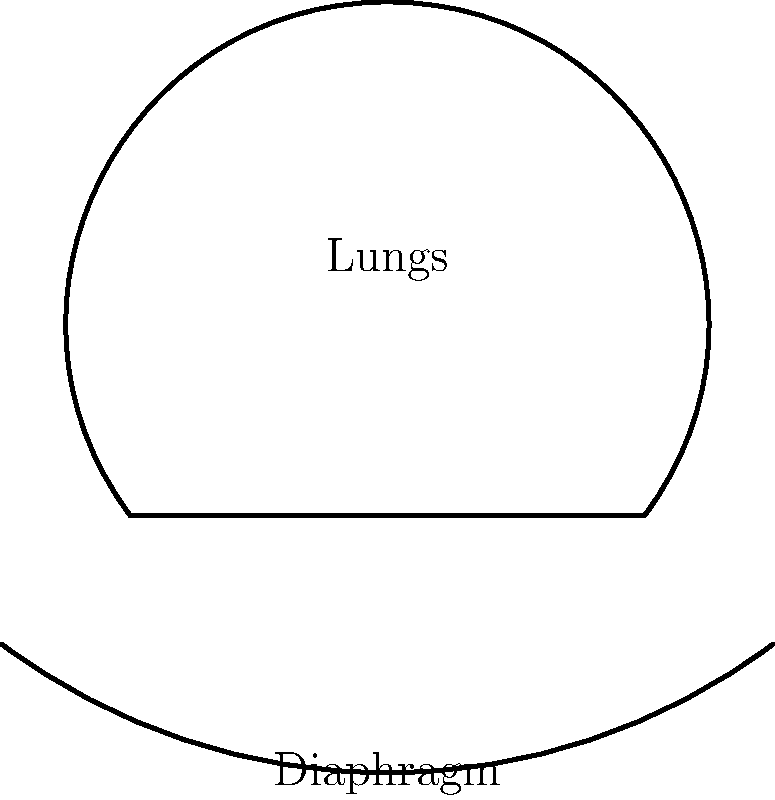In operatic singing, particularly for sustaining long phrases as often required in arias by composers like Verdi or Puccini, which technique is crucial for maintaining consistent air pressure and is illustrated by the blue arrows in the diagram? To answer this question, let's break down the key elements of breath support in operatic singing:

1. Diaphragmatic breathing: The primary muscle used in proper breath support is the diaphragm, shown at the bottom of the lungs in the diagram.

2. Engagement of abdominal muscles: The blue arrows pointing downward illustrate the engagement of the abdominal muscles, which work in conjunction with the diaphragm.

3. Controlled exhalation: The upward blue arrow represents the controlled release of air, which is crucial for sustaining long phrases.

4. Appoggio technique: This Italian term, meaning "to lean," describes the balance between the inhaling and exhaling muscles to maintain consistent air pressure.

5. Steady air pressure: The goal is to maintain steady air pressure throughout the phrase, which allows for consistent tone and volume.

The technique illustrated in the diagram and crucial for maintaining consistent air pressure is the appoggio technique. This technique involves the coordinated use of the diaphragm and abdominal muscles to control the release of air, allowing singers to sustain long phrases with consistent tone and volume.
Answer: Appoggio technique 